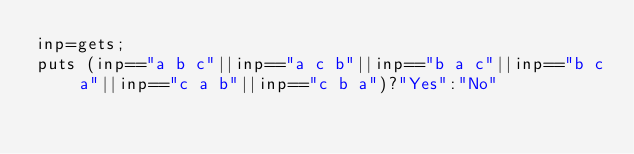Convert code to text. <code><loc_0><loc_0><loc_500><loc_500><_Ruby_>inp=gets;
puts (inp=="a b c"||inp=="a c b"||inp=="b a c"||inp=="b c a"||inp=="c a b"||inp=="c b a")?"Yes":"No"</code> 